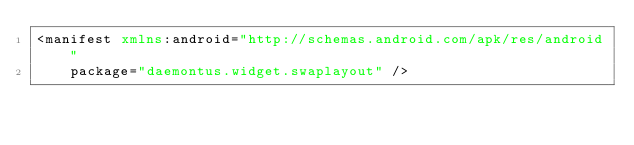Convert code to text. <code><loc_0><loc_0><loc_500><loc_500><_XML_><manifest xmlns:android="http://schemas.android.com/apk/res/android"
    package="daemontus.widget.swaplayout" />
</code> 